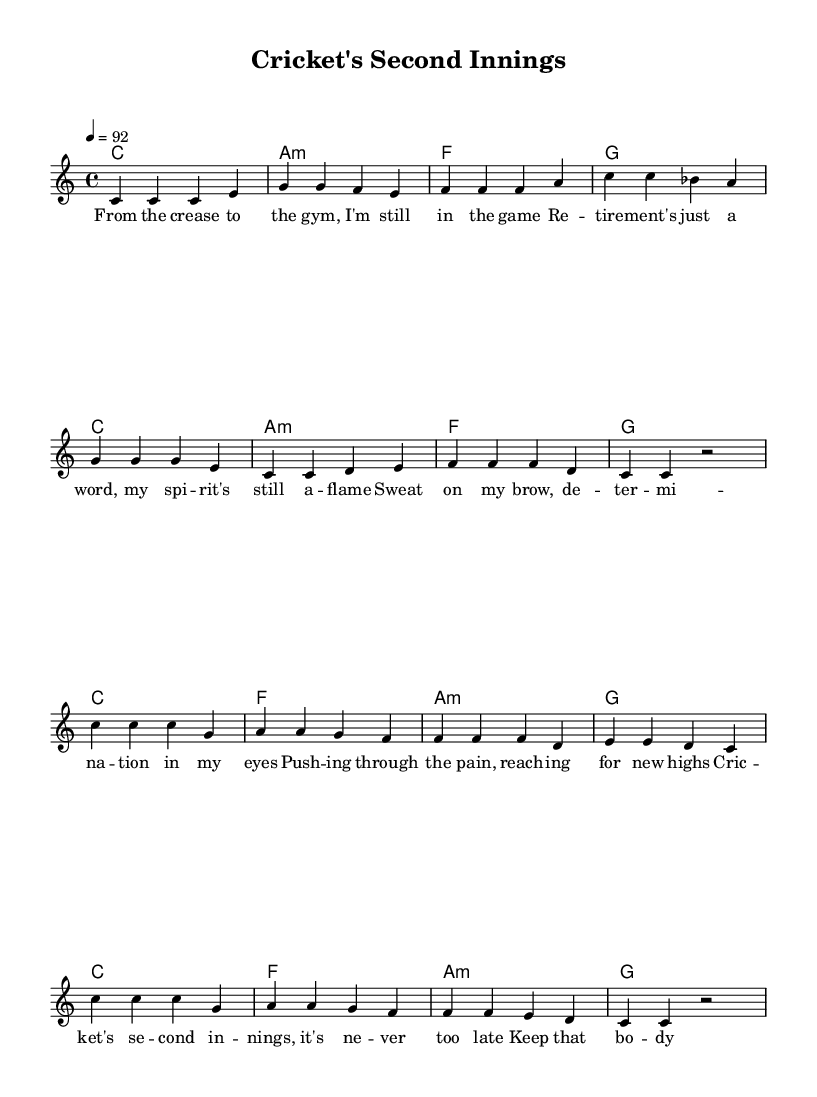What is the key signature of this music? The key signature is C major, which has no sharps or flats.
Answer: C major What is the time signature used in this piece? The time signature is 4/4, indicating four beats per measure, typical for many types of music including reggae.
Answer: 4/4 What is the tempo marking for this sheet music? The tempo marking indicates a speed of 92 beats per minute, which sets the pace for the song.
Answer: 92 How many measures are in the verse section? The verse has eight measures, as indicated by the grouping of notes and bars shown in the music.
Answer: 8 What is the main theme reflected in the lyrics? The main theme focuses on perseverance and staying active post-retirement, encouraging fitness and motivation.
Answer: Perseverance Which musical section contains the phrase "Cric -- ket's se -- cond in -- nings"? This phrase is located in the chorus section of the song, as indicated by the lyrics format beneath the melody.
Answer: Chorus Identify a characteristic element typical of reggae music found in this sheet music. The use of offbeat rhythms is a characteristic element of reggae music, often reflected in the melody and chords.
Answer: Offbeat rhythms 